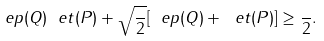<formula> <loc_0><loc_0><loc_500><loc_500>\ e p ( Q ) \ e t ( P ) + \sqrt { \frac { } { 2 } } [ \ e p ( Q ) + \ e t ( P ) ] \geq \frac { } { 2 } .</formula> 